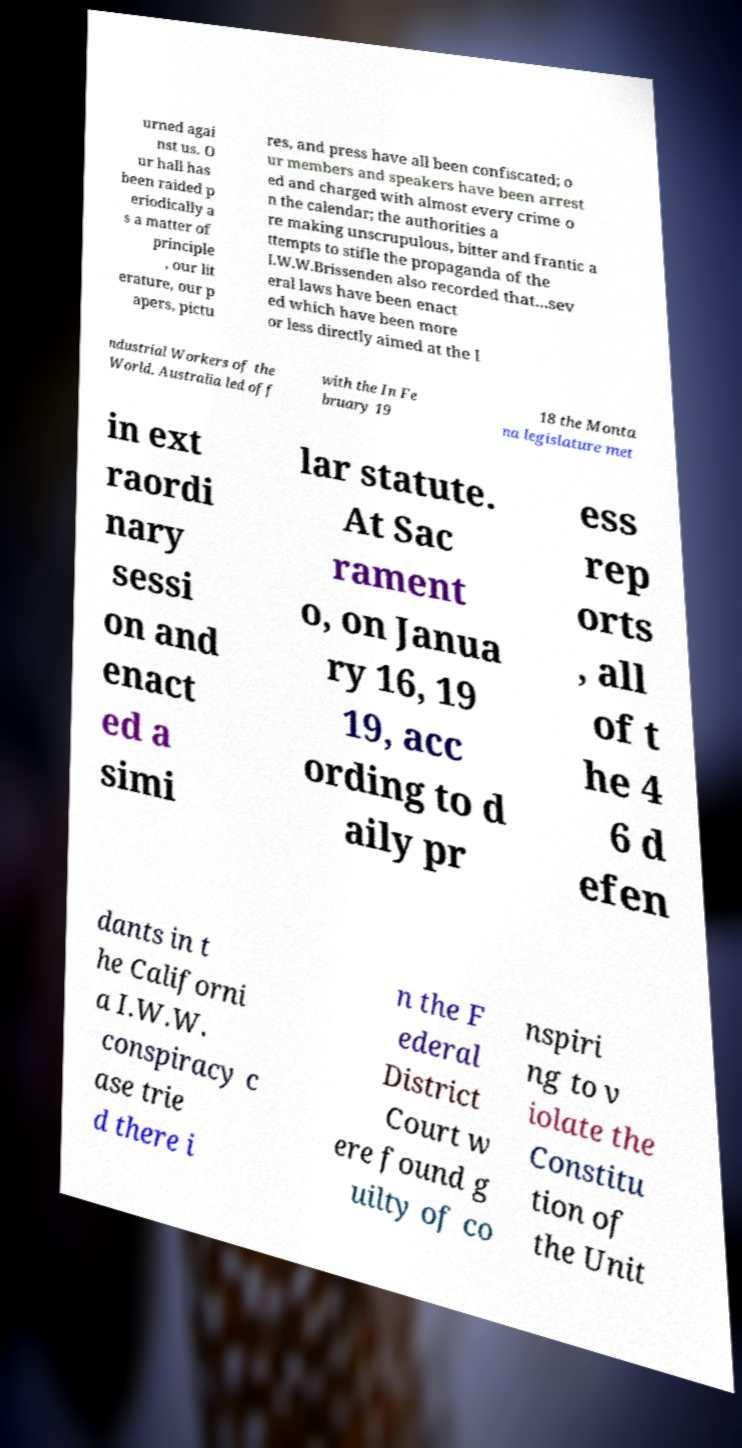I need the written content from this picture converted into text. Can you do that? urned agai nst us. O ur hall has been raided p eriodically a s a matter of principle , our lit erature, our p apers, pictu res, and press have all been confiscated; o ur members and speakers have been arrest ed and charged with almost every crime o n the calendar; the authorities a re making unscrupulous, bitter and frantic a ttempts to stifle the propaganda of the I.W.W.Brissenden also recorded that...sev eral laws have been enact ed which have been more or less directly aimed at the I ndustrial Workers of the World. Australia led off with the In Fe bruary 19 18 the Monta na legislature met in ext raordi nary sessi on and enact ed a simi lar statute. At Sac rament o, on Janua ry 16, 19 19, acc ording to d aily pr ess rep orts , all of t he 4 6 d efen dants in t he Californi a I.W.W. conspiracy c ase trie d there i n the F ederal District Court w ere found g uilty of co nspiri ng to v iolate the Constitu tion of the Unit 